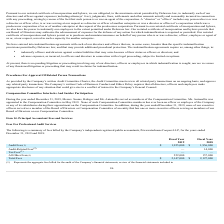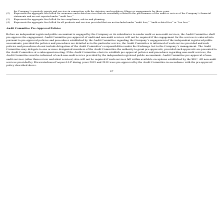According to Xperi Corporation's financial document, What is the name of Xperi Corporation’s independent registered public accountants called? PricewaterhouseCoopers LLP. The document states: "pany’s independent registered public accountants, PricewaterhouseCoopers LLP, for the years ended December 31, 2019 and 2018:..." Also, What does the table show us? a summary of fees billed by the Company’s independent registered public accountants, PricewaterhouseCoopers LLP, for the years ended December 31, 2019 and 2018. The document states: "The following is a summary of fees billed by the Company’s independent registered public accountants, PricewaterhouseCoopers LLP, for the years ended ..." Also, What are the audit fees for the fiscal year 2018 and 2019, respectively? The document shows two values: $1,956,000 and $1,925,000. From the document: "Audit Fees (1) $ 1,925,000 $ 1,956,000 Audit Fees (1) $ 1,925,000 $ 1,956,000..." Also, can you calculate: What is the proportion of audit fees and audit-related fees over total fees in the fiscal year 2018? To answer this question, I need to perform calculations using the financial data. The calculation is: (1,956,000+14,000)/2,127,000 , which equals 0.93. This is based on the information: "Audit Fees (1) $ 1,925,000 $ 1,956,000 Total Fees $ 2,147,000 $ 2,127,000 Audit-Related Fees (2) — 14,000..." The key data points involved are: 1,956,000, 14,000, 2,127,000. Also, can you calculate: What is the percentage change of audit fees from 2018 to 2019? To answer this question, I need to perform calculations using the financial data. The calculation is: (1,925,000-1,956,000)/1,956,000 , which equals -1.58 (percentage). This is based on the information: "Audit Fees (1) $ 1,925,000 $ 1,956,000 Audit Fees (1) $ 1,925,000 $ 1,956,000..." The key data points involved are: 1,925,000, 1,956,000. Also, can you calculate: What is the ratio of total fees in 2019 to total fees in 2018? Based on the calculation: 2,147,000/2,127,000 , the result is 1.01. This is based on the information: "Total Fees $ 2,147,000 $ 2,127,000 Total Fees $ 2,147,000 $ 2,127,000..." The key data points involved are: 2,127,000, 2,147,000. 